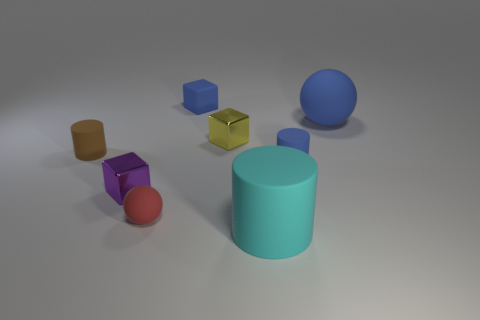Add 1 large gray shiny cylinders. How many objects exist? 9 Subtract all spheres. How many objects are left? 6 Add 6 tiny cylinders. How many tiny cylinders exist? 8 Subtract 1 blue spheres. How many objects are left? 7 Subtract all purple metallic spheres. Subtract all red things. How many objects are left? 7 Add 5 purple blocks. How many purple blocks are left? 6 